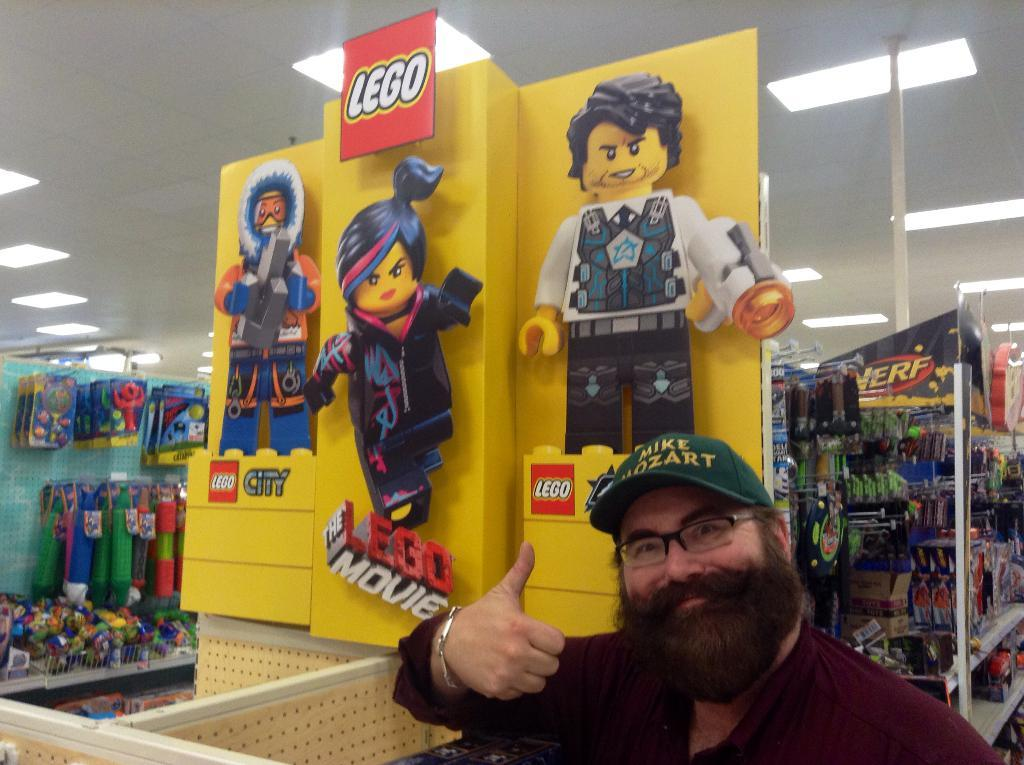What is the main subject of the image? There is a man in the image. Can you describe the man's appearance? The man is wearing a cap and spectacles. What type of images can be seen in the image? There are cartoon pictures in the image. What is the man standing near in the image? There is a board in the image. What type of storage is present in the image? There are racks in the image. What else can be seen in the image? There are other objects in the image. What is visible in the background of the image? The ceiling and lights are visible in the background of the image. How many women are present in the image? There are no women present in the image; it features a man. What type of drug can be seen in the image? There is no drug present in the image. 